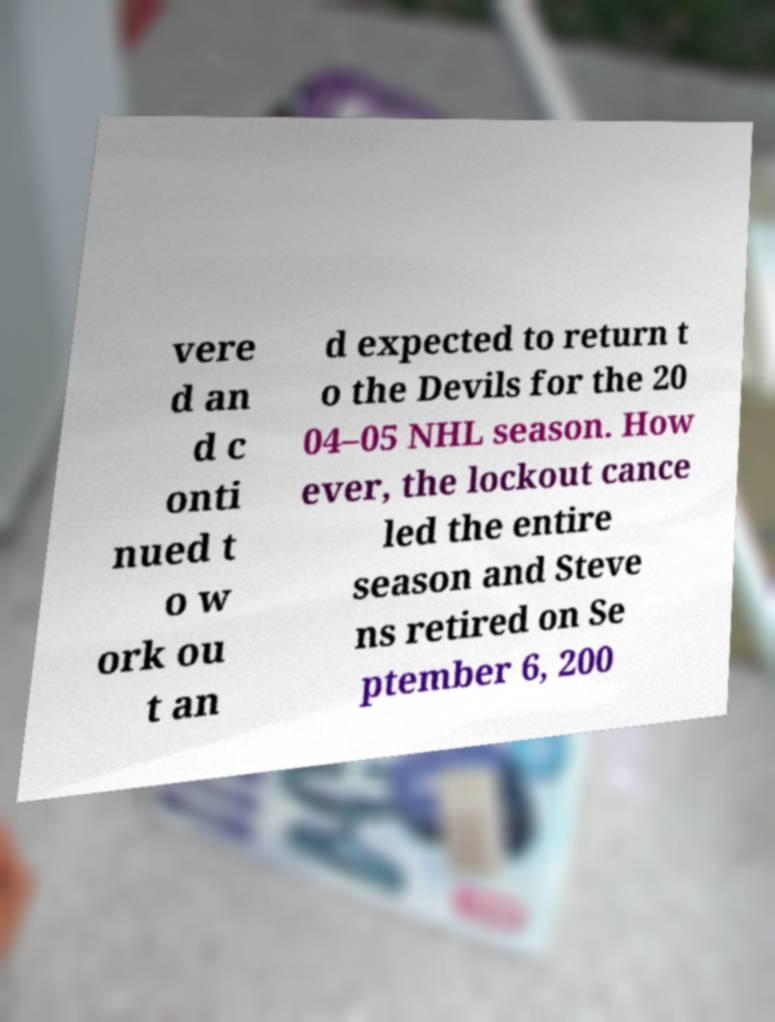There's text embedded in this image that I need extracted. Can you transcribe it verbatim? vere d an d c onti nued t o w ork ou t an d expected to return t o the Devils for the 20 04–05 NHL season. How ever, the lockout cance led the entire season and Steve ns retired on Se ptember 6, 200 